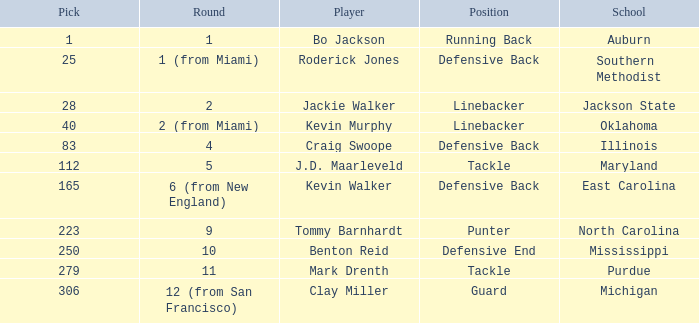What school did bo jackson attend? Auburn. 